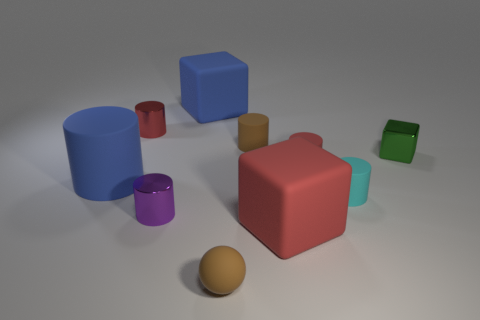Subtract all cyan cylinders. How many cylinders are left? 5 Subtract 3 cylinders. How many cylinders are left? 3 Subtract all purple cylinders. How many cylinders are left? 5 Subtract all blue cylinders. Subtract all cyan balls. How many cylinders are left? 5 Subtract all cylinders. How many objects are left? 4 Subtract all green metal things. Subtract all red metallic things. How many objects are left? 8 Add 4 small red matte cylinders. How many small red matte cylinders are left? 5 Add 7 cyan cylinders. How many cyan cylinders exist? 8 Subtract 2 red cylinders. How many objects are left? 8 